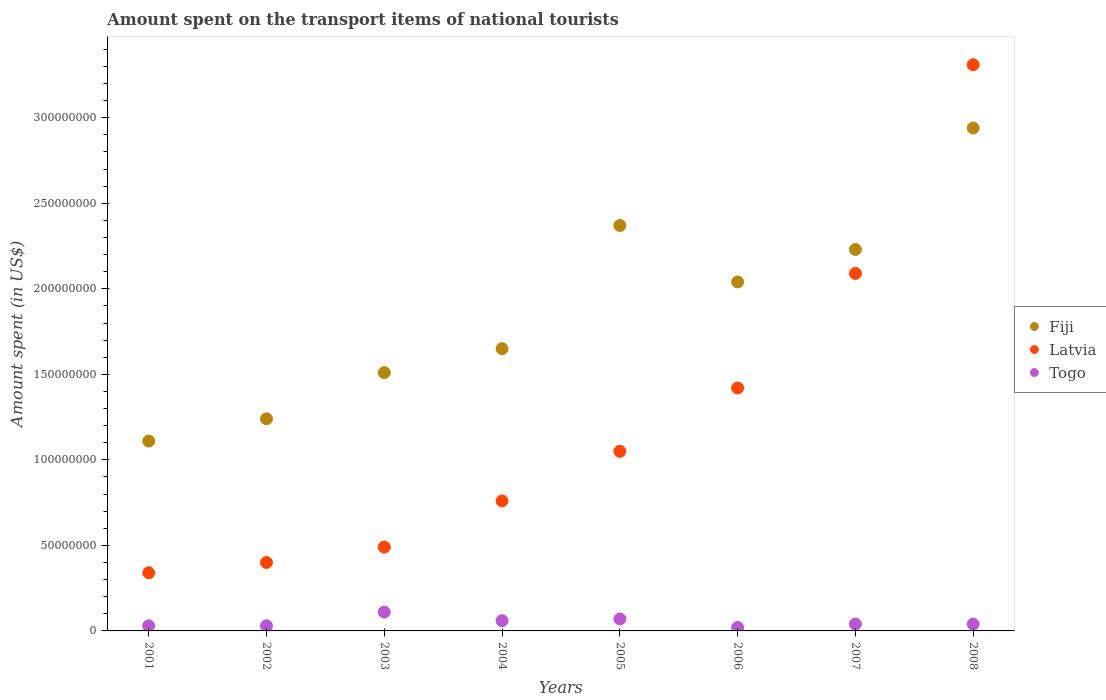Is the number of dotlines equal to the number of legend labels?
Provide a succinct answer. Yes. What is the amount spent on the transport items of national tourists in Fiji in 2002?
Ensure brevity in your answer.  1.24e+08. Across all years, what is the maximum amount spent on the transport items of national tourists in Togo?
Your answer should be very brief. 1.10e+07. Across all years, what is the minimum amount spent on the transport items of national tourists in Latvia?
Keep it short and to the point. 3.40e+07. In which year was the amount spent on the transport items of national tourists in Togo maximum?
Your answer should be compact. 2003. What is the total amount spent on the transport items of national tourists in Latvia in the graph?
Give a very brief answer. 9.86e+08. What is the difference between the amount spent on the transport items of national tourists in Fiji in 2006 and the amount spent on the transport items of national tourists in Togo in 2007?
Provide a succinct answer. 2.00e+08. What is the average amount spent on the transport items of national tourists in Latvia per year?
Your response must be concise. 1.23e+08. In the year 2006, what is the difference between the amount spent on the transport items of national tourists in Latvia and amount spent on the transport items of national tourists in Togo?
Make the answer very short. 1.40e+08. In how many years, is the amount spent on the transport items of national tourists in Fiji greater than 20000000 US$?
Provide a succinct answer. 8. What is the ratio of the amount spent on the transport items of national tourists in Togo in 2001 to that in 2005?
Provide a succinct answer. 0.43. What is the difference between the highest and the second highest amount spent on the transport items of national tourists in Fiji?
Your answer should be compact. 5.70e+07. What is the difference between the highest and the lowest amount spent on the transport items of national tourists in Latvia?
Offer a terse response. 2.97e+08. In how many years, is the amount spent on the transport items of national tourists in Fiji greater than the average amount spent on the transport items of national tourists in Fiji taken over all years?
Keep it short and to the point. 4. Is it the case that in every year, the sum of the amount spent on the transport items of national tourists in Togo and amount spent on the transport items of national tourists in Latvia  is greater than the amount spent on the transport items of national tourists in Fiji?
Provide a short and direct response. No. Does the amount spent on the transport items of national tourists in Fiji monotonically increase over the years?
Your response must be concise. No. Is the amount spent on the transport items of national tourists in Fiji strictly less than the amount spent on the transport items of national tourists in Togo over the years?
Your response must be concise. No. How many years are there in the graph?
Give a very brief answer. 8. Are the values on the major ticks of Y-axis written in scientific E-notation?
Provide a succinct answer. No. Does the graph contain any zero values?
Your answer should be very brief. No. Does the graph contain grids?
Provide a short and direct response. No. How many legend labels are there?
Your answer should be very brief. 3. How are the legend labels stacked?
Your answer should be compact. Vertical. What is the title of the graph?
Make the answer very short. Amount spent on the transport items of national tourists. Does "Moldova" appear as one of the legend labels in the graph?
Your answer should be very brief. No. What is the label or title of the Y-axis?
Provide a succinct answer. Amount spent (in US$). What is the Amount spent (in US$) of Fiji in 2001?
Your answer should be very brief. 1.11e+08. What is the Amount spent (in US$) of Latvia in 2001?
Your answer should be compact. 3.40e+07. What is the Amount spent (in US$) of Togo in 2001?
Ensure brevity in your answer.  3.00e+06. What is the Amount spent (in US$) in Fiji in 2002?
Offer a very short reply. 1.24e+08. What is the Amount spent (in US$) in Latvia in 2002?
Your response must be concise. 4.00e+07. What is the Amount spent (in US$) of Togo in 2002?
Offer a very short reply. 3.00e+06. What is the Amount spent (in US$) in Fiji in 2003?
Your response must be concise. 1.51e+08. What is the Amount spent (in US$) of Latvia in 2003?
Provide a succinct answer. 4.90e+07. What is the Amount spent (in US$) of Togo in 2003?
Make the answer very short. 1.10e+07. What is the Amount spent (in US$) in Fiji in 2004?
Your answer should be compact. 1.65e+08. What is the Amount spent (in US$) in Latvia in 2004?
Your answer should be very brief. 7.60e+07. What is the Amount spent (in US$) in Fiji in 2005?
Keep it short and to the point. 2.37e+08. What is the Amount spent (in US$) of Latvia in 2005?
Give a very brief answer. 1.05e+08. What is the Amount spent (in US$) of Fiji in 2006?
Offer a terse response. 2.04e+08. What is the Amount spent (in US$) in Latvia in 2006?
Offer a terse response. 1.42e+08. What is the Amount spent (in US$) in Togo in 2006?
Provide a short and direct response. 2.00e+06. What is the Amount spent (in US$) of Fiji in 2007?
Keep it short and to the point. 2.23e+08. What is the Amount spent (in US$) in Latvia in 2007?
Your response must be concise. 2.09e+08. What is the Amount spent (in US$) in Togo in 2007?
Your answer should be compact. 4.00e+06. What is the Amount spent (in US$) of Fiji in 2008?
Provide a succinct answer. 2.94e+08. What is the Amount spent (in US$) of Latvia in 2008?
Ensure brevity in your answer.  3.31e+08. Across all years, what is the maximum Amount spent (in US$) of Fiji?
Make the answer very short. 2.94e+08. Across all years, what is the maximum Amount spent (in US$) of Latvia?
Give a very brief answer. 3.31e+08. Across all years, what is the maximum Amount spent (in US$) of Togo?
Make the answer very short. 1.10e+07. Across all years, what is the minimum Amount spent (in US$) of Fiji?
Provide a short and direct response. 1.11e+08. Across all years, what is the minimum Amount spent (in US$) of Latvia?
Make the answer very short. 3.40e+07. What is the total Amount spent (in US$) of Fiji in the graph?
Your answer should be very brief. 1.51e+09. What is the total Amount spent (in US$) in Latvia in the graph?
Offer a very short reply. 9.86e+08. What is the total Amount spent (in US$) in Togo in the graph?
Offer a terse response. 4.00e+07. What is the difference between the Amount spent (in US$) of Fiji in 2001 and that in 2002?
Offer a terse response. -1.30e+07. What is the difference between the Amount spent (in US$) of Latvia in 2001 and that in 2002?
Your answer should be compact. -6.00e+06. What is the difference between the Amount spent (in US$) in Fiji in 2001 and that in 2003?
Keep it short and to the point. -4.00e+07. What is the difference between the Amount spent (in US$) of Latvia in 2001 and that in 2003?
Your answer should be compact. -1.50e+07. What is the difference between the Amount spent (in US$) of Togo in 2001 and that in 2003?
Provide a succinct answer. -8.00e+06. What is the difference between the Amount spent (in US$) of Fiji in 2001 and that in 2004?
Your response must be concise. -5.40e+07. What is the difference between the Amount spent (in US$) in Latvia in 2001 and that in 2004?
Your answer should be very brief. -4.20e+07. What is the difference between the Amount spent (in US$) in Togo in 2001 and that in 2004?
Provide a short and direct response. -3.00e+06. What is the difference between the Amount spent (in US$) in Fiji in 2001 and that in 2005?
Your answer should be compact. -1.26e+08. What is the difference between the Amount spent (in US$) of Latvia in 2001 and that in 2005?
Offer a terse response. -7.10e+07. What is the difference between the Amount spent (in US$) in Fiji in 2001 and that in 2006?
Your answer should be compact. -9.30e+07. What is the difference between the Amount spent (in US$) of Latvia in 2001 and that in 2006?
Your answer should be very brief. -1.08e+08. What is the difference between the Amount spent (in US$) of Fiji in 2001 and that in 2007?
Your response must be concise. -1.12e+08. What is the difference between the Amount spent (in US$) of Latvia in 2001 and that in 2007?
Provide a succinct answer. -1.75e+08. What is the difference between the Amount spent (in US$) of Fiji in 2001 and that in 2008?
Provide a short and direct response. -1.83e+08. What is the difference between the Amount spent (in US$) of Latvia in 2001 and that in 2008?
Offer a very short reply. -2.97e+08. What is the difference between the Amount spent (in US$) of Fiji in 2002 and that in 2003?
Provide a succinct answer. -2.70e+07. What is the difference between the Amount spent (in US$) of Latvia in 2002 and that in 2003?
Your response must be concise. -9.00e+06. What is the difference between the Amount spent (in US$) in Togo in 2002 and that in 2003?
Keep it short and to the point. -8.00e+06. What is the difference between the Amount spent (in US$) of Fiji in 2002 and that in 2004?
Your answer should be very brief. -4.10e+07. What is the difference between the Amount spent (in US$) in Latvia in 2002 and that in 2004?
Your answer should be compact. -3.60e+07. What is the difference between the Amount spent (in US$) in Togo in 2002 and that in 2004?
Your answer should be very brief. -3.00e+06. What is the difference between the Amount spent (in US$) of Fiji in 2002 and that in 2005?
Your answer should be compact. -1.13e+08. What is the difference between the Amount spent (in US$) in Latvia in 2002 and that in 2005?
Provide a succinct answer. -6.50e+07. What is the difference between the Amount spent (in US$) in Fiji in 2002 and that in 2006?
Provide a succinct answer. -8.00e+07. What is the difference between the Amount spent (in US$) of Latvia in 2002 and that in 2006?
Provide a succinct answer. -1.02e+08. What is the difference between the Amount spent (in US$) in Togo in 2002 and that in 2006?
Your response must be concise. 1.00e+06. What is the difference between the Amount spent (in US$) in Fiji in 2002 and that in 2007?
Your answer should be very brief. -9.90e+07. What is the difference between the Amount spent (in US$) in Latvia in 2002 and that in 2007?
Provide a succinct answer. -1.69e+08. What is the difference between the Amount spent (in US$) of Fiji in 2002 and that in 2008?
Keep it short and to the point. -1.70e+08. What is the difference between the Amount spent (in US$) in Latvia in 2002 and that in 2008?
Give a very brief answer. -2.91e+08. What is the difference between the Amount spent (in US$) in Fiji in 2003 and that in 2004?
Ensure brevity in your answer.  -1.40e+07. What is the difference between the Amount spent (in US$) in Latvia in 2003 and that in 2004?
Keep it short and to the point. -2.70e+07. What is the difference between the Amount spent (in US$) in Fiji in 2003 and that in 2005?
Ensure brevity in your answer.  -8.60e+07. What is the difference between the Amount spent (in US$) of Latvia in 2003 and that in 2005?
Offer a very short reply. -5.60e+07. What is the difference between the Amount spent (in US$) of Togo in 2003 and that in 2005?
Provide a short and direct response. 4.00e+06. What is the difference between the Amount spent (in US$) of Fiji in 2003 and that in 2006?
Give a very brief answer. -5.30e+07. What is the difference between the Amount spent (in US$) of Latvia in 2003 and that in 2006?
Offer a terse response. -9.30e+07. What is the difference between the Amount spent (in US$) of Togo in 2003 and that in 2006?
Your answer should be compact. 9.00e+06. What is the difference between the Amount spent (in US$) of Fiji in 2003 and that in 2007?
Your answer should be compact. -7.20e+07. What is the difference between the Amount spent (in US$) in Latvia in 2003 and that in 2007?
Make the answer very short. -1.60e+08. What is the difference between the Amount spent (in US$) of Fiji in 2003 and that in 2008?
Ensure brevity in your answer.  -1.43e+08. What is the difference between the Amount spent (in US$) in Latvia in 2003 and that in 2008?
Give a very brief answer. -2.82e+08. What is the difference between the Amount spent (in US$) of Togo in 2003 and that in 2008?
Make the answer very short. 7.00e+06. What is the difference between the Amount spent (in US$) in Fiji in 2004 and that in 2005?
Your answer should be very brief. -7.20e+07. What is the difference between the Amount spent (in US$) in Latvia in 2004 and that in 2005?
Provide a short and direct response. -2.90e+07. What is the difference between the Amount spent (in US$) of Togo in 2004 and that in 2005?
Offer a very short reply. -1.00e+06. What is the difference between the Amount spent (in US$) of Fiji in 2004 and that in 2006?
Provide a succinct answer. -3.90e+07. What is the difference between the Amount spent (in US$) in Latvia in 2004 and that in 2006?
Your answer should be compact. -6.60e+07. What is the difference between the Amount spent (in US$) in Fiji in 2004 and that in 2007?
Your answer should be very brief. -5.80e+07. What is the difference between the Amount spent (in US$) in Latvia in 2004 and that in 2007?
Your answer should be very brief. -1.33e+08. What is the difference between the Amount spent (in US$) in Fiji in 2004 and that in 2008?
Your response must be concise. -1.29e+08. What is the difference between the Amount spent (in US$) in Latvia in 2004 and that in 2008?
Keep it short and to the point. -2.55e+08. What is the difference between the Amount spent (in US$) of Fiji in 2005 and that in 2006?
Provide a succinct answer. 3.30e+07. What is the difference between the Amount spent (in US$) in Latvia in 2005 and that in 2006?
Your response must be concise. -3.70e+07. What is the difference between the Amount spent (in US$) of Fiji in 2005 and that in 2007?
Offer a very short reply. 1.40e+07. What is the difference between the Amount spent (in US$) in Latvia in 2005 and that in 2007?
Provide a succinct answer. -1.04e+08. What is the difference between the Amount spent (in US$) in Fiji in 2005 and that in 2008?
Provide a short and direct response. -5.70e+07. What is the difference between the Amount spent (in US$) of Latvia in 2005 and that in 2008?
Keep it short and to the point. -2.26e+08. What is the difference between the Amount spent (in US$) of Togo in 2005 and that in 2008?
Offer a very short reply. 3.00e+06. What is the difference between the Amount spent (in US$) in Fiji in 2006 and that in 2007?
Offer a very short reply. -1.90e+07. What is the difference between the Amount spent (in US$) in Latvia in 2006 and that in 2007?
Provide a short and direct response. -6.70e+07. What is the difference between the Amount spent (in US$) in Fiji in 2006 and that in 2008?
Your answer should be very brief. -9.00e+07. What is the difference between the Amount spent (in US$) in Latvia in 2006 and that in 2008?
Offer a very short reply. -1.89e+08. What is the difference between the Amount spent (in US$) of Fiji in 2007 and that in 2008?
Make the answer very short. -7.10e+07. What is the difference between the Amount spent (in US$) in Latvia in 2007 and that in 2008?
Your answer should be very brief. -1.22e+08. What is the difference between the Amount spent (in US$) of Fiji in 2001 and the Amount spent (in US$) of Latvia in 2002?
Provide a succinct answer. 7.10e+07. What is the difference between the Amount spent (in US$) in Fiji in 2001 and the Amount spent (in US$) in Togo in 2002?
Provide a short and direct response. 1.08e+08. What is the difference between the Amount spent (in US$) of Latvia in 2001 and the Amount spent (in US$) of Togo in 2002?
Offer a very short reply. 3.10e+07. What is the difference between the Amount spent (in US$) in Fiji in 2001 and the Amount spent (in US$) in Latvia in 2003?
Provide a succinct answer. 6.20e+07. What is the difference between the Amount spent (in US$) in Fiji in 2001 and the Amount spent (in US$) in Togo in 2003?
Your response must be concise. 1.00e+08. What is the difference between the Amount spent (in US$) in Latvia in 2001 and the Amount spent (in US$) in Togo in 2003?
Ensure brevity in your answer.  2.30e+07. What is the difference between the Amount spent (in US$) of Fiji in 2001 and the Amount spent (in US$) of Latvia in 2004?
Provide a short and direct response. 3.50e+07. What is the difference between the Amount spent (in US$) of Fiji in 2001 and the Amount spent (in US$) of Togo in 2004?
Keep it short and to the point. 1.05e+08. What is the difference between the Amount spent (in US$) in Latvia in 2001 and the Amount spent (in US$) in Togo in 2004?
Provide a succinct answer. 2.80e+07. What is the difference between the Amount spent (in US$) of Fiji in 2001 and the Amount spent (in US$) of Latvia in 2005?
Your answer should be compact. 6.00e+06. What is the difference between the Amount spent (in US$) in Fiji in 2001 and the Amount spent (in US$) in Togo in 2005?
Ensure brevity in your answer.  1.04e+08. What is the difference between the Amount spent (in US$) in Latvia in 2001 and the Amount spent (in US$) in Togo in 2005?
Offer a terse response. 2.70e+07. What is the difference between the Amount spent (in US$) in Fiji in 2001 and the Amount spent (in US$) in Latvia in 2006?
Your answer should be compact. -3.10e+07. What is the difference between the Amount spent (in US$) in Fiji in 2001 and the Amount spent (in US$) in Togo in 2006?
Your answer should be very brief. 1.09e+08. What is the difference between the Amount spent (in US$) in Latvia in 2001 and the Amount spent (in US$) in Togo in 2006?
Ensure brevity in your answer.  3.20e+07. What is the difference between the Amount spent (in US$) in Fiji in 2001 and the Amount spent (in US$) in Latvia in 2007?
Keep it short and to the point. -9.80e+07. What is the difference between the Amount spent (in US$) in Fiji in 2001 and the Amount spent (in US$) in Togo in 2007?
Keep it short and to the point. 1.07e+08. What is the difference between the Amount spent (in US$) of Latvia in 2001 and the Amount spent (in US$) of Togo in 2007?
Provide a succinct answer. 3.00e+07. What is the difference between the Amount spent (in US$) of Fiji in 2001 and the Amount spent (in US$) of Latvia in 2008?
Offer a very short reply. -2.20e+08. What is the difference between the Amount spent (in US$) of Fiji in 2001 and the Amount spent (in US$) of Togo in 2008?
Make the answer very short. 1.07e+08. What is the difference between the Amount spent (in US$) in Latvia in 2001 and the Amount spent (in US$) in Togo in 2008?
Offer a terse response. 3.00e+07. What is the difference between the Amount spent (in US$) of Fiji in 2002 and the Amount spent (in US$) of Latvia in 2003?
Keep it short and to the point. 7.50e+07. What is the difference between the Amount spent (in US$) in Fiji in 2002 and the Amount spent (in US$) in Togo in 2003?
Keep it short and to the point. 1.13e+08. What is the difference between the Amount spent (in US$) in Latvia in 2002 and the Amount spent (in US$) in Togo in 2003?
Ensure brevity in your answer.  2.90e+07. What is the difference between the Amount spent (in US$) of Fiji in 2002 and the Amount spent (in US$) of Latvia in 2004?
Give a very brief answer. 4.80e+07. What is the difference between the Amount spent (in US$) in Fiji in 2002 and the Amount spent (in US$) in Togo in 2004?
Ensure brevity in your answer.  1.18e+08. What is the difference between the Amount spent (in US$) of Latvia in 2002 and the Amount spent (in US$) of Togo in 2004?
Make the answer very short. 3.40e+07. What is the difference between the Amount spent (in US$) of Fiji in 2002 and the Amount spent (in US$) of Latvia in 2005?
Your answer should be very brief. 1.90e+07. What is the difference between the Amount spent (in US$) in Fiji in 2002 and the Amount spent (in US$) in Togo in 2005?
Your answer should be compact. 1.17e+08. What is the difference between the Amount spent (in US$) in Latvia in 2002 and the Amount spent (in US$) in Togo in 2005?
Provide a short and direct response. 3.30e+07. What is the difference between the Amount spent (in US$) of Fiji in 2002 and the Amount spent (in US$) of Latvia in 2006?
Your answer should be very brief. -1.80e+07. What is the difference between the Amount spent (in US$) in Fiji in 2002 and the Amount spent (in US$) in Togo in 2006?
Your answer should be very brief. 1.22e+08. What is the difference between the Amount spent (in US$) in Latvia in 2002 and the Amount spent (in US$) in Togo in 2006?
Give a very brief answer. 3.80e+07. What is the difference between the Amount spent (in US$) in Fiji in 2002 and the Amount spent (in US$) in Latvia in 2007?
Your answer should be compact. -8.50e+07. What is the difference between the Amount spent (in US$) in Fiji in 2002 and the Amount spent (in US$) in Togo in 2007?
Your answer should be very brief. 1.20e+08. What is the difference between the Amount spent (in US$) of Latvia in 2002 and the Amount spent (in US$) of Togo in 2007?
Make the answer very short. 3.60e+07. What is the difference between the Amount spent (in US$) in Fiji in 2002 and the Amount spent (in US$) in Latvia in 2008?
Your answer should be compact. -2.07e+08. What is the difference between the Amount spent (in US$) of Fiji in 2002 and the Amount spent (in US$) of Togo in 2008?
Keep it short and to the point. 1.20e+08. What is the difference between the Amount spent (in US$) of Latvia in 2002 and the Amount spent (in US$) of Togo in 2008?
Provide a succinct answer. 3.60e+07. What is the difference between the Amount spent (in US$) in Fiji in 2003 and the Amount spent (in US$) in Latvia in 2004?
Make the answer very short. 7.50e+07. What is the difference between the Amount spent (in US$) in Fiji in 2003 and the Amount spent (in US$) in Togo in 2004?
Give a very brief answer. 1.45e+08. What is the difference between the Amount spent (in US$) of Latvia in 2003 and the Amount spent (in US$) of Togo in 2004?
Offer a terse response. 4.30e+07. What is the difference between the Amount spent (in US$) of Fiji in 2003 and the Amount spent (in US$) of Latvia in 2005?
Keep it short and to the point. 4.60e+07. What is the difference between the Amount spent (in US$) in Fiji in 2003 and the Amount spent (in US$) in Togo in 2005?
Your answer should be compact. 1.44e+08. What is the difference between the Amount spent (in US$) in Latvia in 2003 and the Amount spent (in US$) in Togo in 2005?
Your answer should be compact. 4.20e+07. What is the difference between the Amount spent (in US$) of Fiji in 2003 and the Amount spent (in US$) of Latvia in 2006?
Your answer should be very brief. 9.00e+06. What is the difference between the Amount spent (in US$) of Fiji in 2003 and the Amount spent (in US$) of Togo in 2006?
Ensure brevity in your answer.  1.49e+08. What is the difference between the Amount spent (in US$) in Latvia in 2003 and the Amount spent (in US$) in Togo in 2006?
Your answer should be very brief. 4.70e+07. What is the difference between the Amount spent (in US$) in Fiji in 2003 and the Amount spent (in US$) in Latvia in 2007?
Provide a short and direct response. -5.80e+07. What is the difference between the Amount spent (in US$) in Fiji in 2003 and the Amount spent (in US$) in Togo in 2007?
Provide a short and direct response. 1.47e+08. What is the difference between the Amount spent (in US$) in Latvia in 2003 and the Amount spent (in US$) in Togo in 2007?
Ensure brevity in your answer.  4.50e+07. What is the difference between the Amount spent (in US$) in Fiji in 2003 and the Amount spent (in US$) in Latvia in 2008?
Provide a succinct answer. -1.80e+08. What is the difference between the Amount spent (in US$) in Fiji in 2003 and the Amount spent (in US$) in Togo in 2008?
Ensure brevity in your answer.  1.47e+08. What is the difference between the Amount spent (in US$) of Latvia in 2003 and the Amount spent (in US$) of Togo in 2008?
Offer a terse response. 4.50e+07. What is the difference between the Amount spent (in US$) in Fiji in 2004 and the Amount spent (in US$) in Latvia in 2005?
Make the answer very short. 6.00e+07. What is the difference between the Amount spent (in US$) in Fiji in 2004 and the Amount spent (in US$) in Togo in 2005?
Provide a succinct answer. 1.58e+08. What is the difference between the Amount spent (in US$) of Latvia in 2004 and the Amount spent (in US$) of Togo in 2005?
Keep it short and to the point. 6.90e+07. What is the difference between the Amount spent (in US$) of Fiji in 2004 and the Amount spent (in US$) of Latvia in 2006?
Your response must be concise. 2.30e+07. What is the difference between the Amount spent (in US$) of Fiji in 2004 and the Amount spent (in US$) of Togo in 2006?
Give a very brief answer. 1.63e+08. What is the difference between the Amount spent (in US$) of Latvia in 2004 and the Amount spent (in US$) of Togo in 2006?
Provide a short and direct response. 7.40e+07. What is the difference between the Amount spent (in US$) in Fiji in 2004 and the Amount spent (in US$) in Latvia in 2007?
Offer a terse response. -4.40e+07. What is the difference between the Amount spent (in US$) in Fiji in 2004 and the Amount spent (in US$) in Togo in 2007?
Offer a very short reply. 1.61e+08. What is the difference between the Amount spent (in US$) of Latvia in 2004 and the Amount spent (in US$) of Togo in 2007?
Your answer should be very brief. 7.20e+07. What is the difference between the Amount spent (in US$) in Fiji in 2004 and the Amount spent (in US$) in Latvia in 2008?
Provide a succinct answer. -1.66e+08. What is the difference between the Amount spent (in US$) in Fiji in 2004 and the Amount spent (in US$) in Togo in 2008?
Your answer should be compact. 1.61e+08. What is the difference between the Amount spent (in US$) of Latvia in 2004 and the Amount spent (in US$) of Togo in 2008?
Make the answer very short. 7.20e+07. What is the difference between the Amount spent (in US$) of Fiji in 2005 and the Amount spent (in US$) of Latvia in 2006?
Keep it short and to the point. 9.50e+07. What is the difference between the Amount spent (in US$) in Fiji in 2005 and the Amount spent (in US$) in Togo in 2006?
Offer a terse response. 2.35e+08. What is the difference between the Amount spent (in US$) in Latvia in 2005 and the Amount spent (in US$) in Togo in 2006?
Offer a very short reply. 1.03e+08. What is the difference between the Amount spent (in US$) of Fiji in 2005 and the Amount spent (in US$) of Latvia in 2007?
Offer a very short reply. 2.80e+07. What is the difference between the Amount spent (in US$) of Fiji in 2005 and the Amount spent (in US$) of Togo in 2007?
Your answer should be very brief. 2.33e+08. What is the difference between the Amount spent (in US$) of Latvia in 2005 and the Amount spent (in US$) of Togo in 2007?
Give a very brief answer. 1.01e+08. What is the difference between the Amount spent (in US$) in Fiji in 2005 and the Amount spent (in US$) in Latvia in 2008?
Offer a terse response. -9.40e+07. What is the difference between the Amount spent (in US$) of Fiji in 2005 and the Amount spent (in US$) of Togo in 2008?
Keep it short and to the point. 2.33e+08. What is the difference between the Amount spent (in US$) in Latvia in 2005 and the Amount spent (in US$) in Togo in 2008?
Ensure brevity in your answer.  1.01e+08. What is the difference between the Amount spent (in US$) of Fiji in 2006 and the Amount spent (in US$) of Latvia in 2007?
Offer a very short reply. -5.00e+06. What is the difference between the Amount spent (in US$) in Fiji in 2006 and the Amount spent (in US$) in Togo in 2007?
Provide a succinct answer. 2.00e+08. What is the difference between the Amount spent (in US$) in Latvia in 2006 and the Amount spent (in US$) in Togo in 2007?
Your answer should be compact. 1.38e+08. What is the difference between the Amount spent (in US$) in Fiji in 2006 and the Amount spent (in US$) in Latvia in 2008?
Provide a short and direct response. -1.27e+08. What is the difference between the Amount spent (in US$) of Fiji in 2006 and the Amount spent (in US$) of Togo in 2008?
Offer a terse response. 2.00e+08. What is the difference between the Amount spent (in US$) in Latvia in 2006 and the Amount spent (in US$) in Togo in 2008?
Your response must be concise. 1.38e+08. What is the difference between the Amount spent (in US$) of Fiji in 2007 and the Amount spent (in US$) of Latvia in 2008?
Your answer should be compact. -1.08e+08. What is the difference between the Amount spent (in US$) of Fiji in 2007 and the Amount spent (in US$) of Togo in 2008?
Keep it short and to the point. 2.19e+08. What is the difference between the Amount spent (in US$) in Latvia in 2007 and the Amount spent (in US$) in Togo in 2008?
Make the answer very short. 2.05e+08. What is the average Amount spent (in US$) in Fiji per year?
Your answer should be very brief. 1.89e+08. What is the average Amount spent (in US$) of Latvia per year?
Offer a terse response. 1.23e+08. What is the average Amount spent (in US$) of Togo per year?
Your answer should be very brief. 5.00e+06. In the year 2001, what is the difference between the Amount spent (in US$) in Fiji and Amount spent (in US$) in Latvia?
Make the answer very short. 7.70e+07. In the year 2001, what is the difference between the Amount spent (in US$) in Fiji and Amount spent (in US$) in Togo?
Offer a very short reply. 1.08e+08. In the year 2001, what is the difference between the Amount spent (in US$) in Latvia and Amount spent (in US$) in Togo?
Provide a short and direct response. 3.10e+07. In the year 2002, what is the difference between the Amount spent (in US$) of Fiji and Amount spent (in US$) of Latvia?
Offer a terse response. 8.40e+07. In the year 2002, what is the difference between the Amount spent (in US$) of Fiji and Amount spent (in US$) of Togo?
Provide a succinct answer. 1.21e+08. In the year 2002, what is the difference between the Amount spent (in US$) in Latvia and Amount spent (in US$) in Togo?
Your answer should be very brief. 3.70e+07. In the year 2003, what is the difference between the Amount spent (in US$) of Fiji and Amount spent (in US$) of Latvia?
Your response must be concise. 1.02e+08. In the year 2003, what is the difference between the Amount spent (in US$) of Fiji and Amount spent (in US$) of Togo?
Your response must be concise. 1.40e+08. In the year 2003, what is the difference between the Amount spent (in US$) of Latvia and Amount spent (in US$) of Togo?
Offer a terse response. 3.80e+07. In the year 2004, what is the difference between the Amount spent (in US$) in Fiji and Amount spent (in US$) in Latvia?
Keep it short and to the point. 8.90e+07. In the year 2004, what is the difference between the Amount spent (in US$) in Fiji and Amount spent (in US$) in Togo?
Give a very brief answer. 1.59e+08. In the year 2004, what is the difference between the Amount spent (in US$) of Latvia and Amount spent (in US$) of Togo?
Make the answer very short. 7.00e+07. In the year 2005, what is the difference between the Amount spent (in US$) in Fiji and Amount spent (in US$) in Latvia?
Ensure brevity in your answer.  1.32e+08. In the year 2005, what is the difference between the Amount spent (in US$) of Fiji and Amount spent (in US$) of Togo?
Offer a very short reply. 2.30e+08. In the year 2005, what is the difference between the Amount spent (in US$) of Latvia and Amount spent (in US$) of Togo?
Ensure brevity in your answer.  9.80e+07. In the year 2006, what is the difference between the Amount spent (in US$) of Fiji and Amount spent (in US$) of Latvia?
Offer a very short reply. 6.20e+07. In the year 2006, what is the difference between the Amount spent (in US$) of Fiji and Amount spent (in US$) of Togo?
Offer a terse response. 2.02e+08. In the year 2006, what is the difference between the Amount spent (in US$) of Latvia and Amount spent (in US$) of Togo?
Ensure brevity in your answer.  1.40e+08. In the year 2007, what is the difference between the Amount spent (in US$) in Fiji and Amount spent (in US$) in Latvia?
Give a very brief answer. 1.40e+07. In the year 2007, what is the difference between the Amount spent (in US$) of Fiji and Amount spent (in US$) of Togo?
Provide a succinct answer. 2.19e+08. In the year 2007, what is the difference between the Amount spent (in US$) in Latvia and Amount spent (in US$) in Togo?
Offer a terse response. 2.05e+08. In the year 2008, what is the difference between the Amount spent (in US$) in Fiji and Amount spent (in US$) in Latvia?
Keep it short and to the point. -3.70e+07. In the year 2008, what is the difference between the Amount spent (in US$) of Fiji and Amount spent (in US$) of Togo?
Offer a very short reply. 2.90e+08. In the year 2008, what is the difference between the Amount spent (in US$) of Latvia and Amount spent (in US$) of Togo?
Provide a succinct answer. 3.27e+08. What is the ratio of the Amount spent (in US$) of Fiji in 2001 to that in 2002?
Ensure brevity in your answer.  0.9. What is the ratio of the Amount spent (in US$) of Fiji in 2001 to that in 2003?
Your answer should be very brief. 0.74. What is the ratio of the Amount spent (in US$) in Latvia in 2001 to that in 2003?
Offer a terse response. 0.69. What is the ratio of the Amount spent (in US$) of Togo in 2001 to that in 2003?
Offer a very short reply. 0.27. What is the ratio of the Amount spent (in US$) in Fiji in 2001 to that in 2004?
Offer a terse response. 0.67. What is the ratio of the Amount spent (in US$) of Latvia in 2001 to that in 2004?
Provide a short and direct response. 0.45. What is the ratio of the Amount spent (in US$) in Togo in 2001 to that in 2004?
Offer a terse response. 0.5. What is the ratio of the Amount spent (in US$) in Fiji in 2001 to that in 2005?
Keep it short and to the point. 0.47. What is the ratio of the Amount spent (in US$) of Latvia in 2001 to that in 2005?
Your answer should be compact. 0.32. What is the ratio of the Amount spent (in US$) of Togo in 2001 to that in 2005?
Your response must be concise. 0.43. What is the ratio of the Amount spent (in US$) of Fiji in 2001 to that in 2006?
Make the answer very short. 0.54. What is the ratio of the Amount spent (in US$) in Latvia in 2001 to that in 2006?
Offer a terse response. 0.24. What is the ratio of the Amount spent (in US$) in Togo in 2001 to that in 2006?
Your answer should be compact. 1.5. What is the ratio of the Amount spent (in US$) of Fiji in 2001 to that in 2007?
Provide a succinct answer. 0.5. What is the ratio of the Amount spent (in US$) in Latvia in 2001 to that in 2007?
Make the answer very short. 0.16. What is the ratio of the Amount spent (in US$) in Togo in 2001 to that in 2007?
Offer a terse response. 0.75. What is the ratio of the Amount spent (in US$) in Fiji in 2001 to that in 2008?
Ensure brevity in your answer.  0.38. What is the ratio of the Amount spent (in US$) in Latvia in 2001 to that in 2008?
Give a very brief answer. 0.1. What is the ratio of the Amount spent (in US$) in Togo in 2001 to that in 2008?
Your response must be concise. 0.75. What is the ratio of the Amount spent (in US$) of Fiji in 2002 to that in 2003?
Give a very brief answer. 0.82. What is the ratio of the Amount spent (in US$) of Latvia in 2002 to that in 2003?
Provide a short and direct response. 0.82. What is the ratio of the Amount spent (in US$) in Togo in 2002 to that in 2003?
Provide a short and direct response. 0.27. What is the ratio of the Amount spent (in US$) in Fiji in 2002 to that in 2004?
Your response must be concise. 0.75. What is the ratio of the Amount spent (in US$) in Latvia in 2002 to that in 2004?
Your answer should be compact. 0.53. What is the ratio of the Amount spent (in US$) of Togo in 2002 to that in 2004?
Keep it short and to the point. 0.5. What is the ratio of the Amount spent (in US$) of Fiji in 2002 to that in 2005?
Your answer should be compact. 0.52. What is the ratio of the Amount spent (in US$) in Latvia in 2002 to that in 2005?
Your answer should be very brief. 0.38. What is the ratio of the Amount spent (in US$) of Togo in 2002 to that in 2005?
Your response must be concise. 0.43. What is the ratio of the Amount spent (in US$) in Fiji in 2002 to that in 2006?
Provide a short and direct response. 0.61. What is the ratio of the Amount spent (in US$) in Latvia in 2002 to that in 2006?
Provide a short and direct response. 0.28. What is the ratio of the Amount spent (in US$) of Fiji in 2002 to that in 2007?
Provide a succinct answer. 0.56. What is the ratio of the Amount spent (in US$) of Latvia in 2002 to that in 2007?
Give a very brief answer. 0.19. What is the ratio of the Amount spent (in US$) in Togo in 2002 to that in 2007?
Offer a very short reply. 0.75. What is the ratio of the Amount spent (in US$) of Fiji in 2002 to that in 2008?
Make the answer very short. 0.42. What is the ratio of the Amount spent (in US$) in Latvia in 2002 to that in 2008?
Provide a short and direct response. 0.12. What is the ratio of the Amount spent (in US$) of Fiji in 2003 to that in 2004?
Offer a very short reply. 0.92. What is the ratio of the Amount spent (in US$) in Latvia in 2003 to that in 2004?
Offer a very short reply. 0.64. What is the ratio of the Amount spent (in US$) of Togo in 2003 to that in 2004?
Provide a succinct answer. 1.83. What is the ratio of the Amount spent (in US$) of Fiji in 2003 to that in 2005?
Your response must be concise. 0.64. What is the ratio of the Amount spent (in US$) of Latvia in 2003 to that in 2005?
Make the answer very short. 0.47. What is the ratio of the Amount spent (in US$) of Togo in 2003 to that in 2005?
Keep it short and to the point. 1.57. What is the ratio of the Amount spent (in US$) in Fiji in 2003 to that in 2006?
Keep it short and to the point. 0.74. What is the ratio of the Amount spent (in US$) of Latvia in 2003 to that in 2006?
Offer a terse response. 0.35. What is the ratio of the Amount spent (in US$) of Fiji in 2003 to that in 2007?
Your answer should be compact. 0.68. What is the ratio of the Amount spent (in US$) of Latvia in 2003 to that in 2007?
Your answer should be compact. 0.23. What is the ratio of the Amount spent (in US$) of Togo in 2003 to that in 2007?
Offer a terse response. 2.75. What is the ratio of the Amount spent (in US$) in Fiji in 2003 to that in 2008?
Offer a terse response. 0.51. What is the ratio of the Amount spent (in US$) of Latvia in 2003 to that in 2008?
Keep it short and to the point. 0.15. What is the ratio of the Amount spent (in US$) of Togo in 2003 to that in 2008?
Offer a very short reply. 2.75. What is the ratio of the Amount spent (in US$) of Fiji in 2004 to that in 2005?
Your answer should be compact. 0.7. What is the ratio of the Amount spent (in US$) of Latvia in 2004 to that in 2005?
Provide a succinct answer. 0.72. What is the ratio of the Amount spent (in US$) in Togo in 2004 to that in 2005?
Provide a succinct answer. 0.86. What is the ratio of the Amount spent (in US$) of Fiji in 2004 to that in 2006?
Ensure brevity in your answer.  0.81. What is the ratio of the Amount spent (in US$) in Latvia in 2004 to that in 2006?
Offer a terse response. 0.54. What is the ratio of the Amount spent (in US$) of Fiji in 2004 to that in 2007?
Your answer should be compact. 0.74. What is the ratio of the Amount spent (in US$) in Latvia in 2004 to that in 2007?
Provide a succinct answer. 0.36. What is the ratio of the Amount spent (in US$) of Fiji in 2004 to that in 2008?
Give a very brief answer. 0.56. What is the ratio of the Amount spent (in US$) in Latvia in 2004 to that in 2008?
Your answer should be very brief. 0.23. What is the ratio of the Amount spent (in US$) of Togo in 2004 to that in 2008?
Give a very brief answer. 1.5. What is the ratio of the Amount spent (in US$) of Fiji in 2005 to that in 2006?
Your answer should be compact. 1.16. What is the ratio of the Amount spent (in US$) in Latvia in 2005 to that in 2006?
Your answer should be compact. 0.74. What is the ratio of the Amount spent (in US$) in Fiji in 2005 to that in 2007?
Keep it short and to the point. 1.06. What is the ratio of the Amount spent (in US$) in Latvia in 2005 to that in 2007?
Keep it short and to the point. 0.5. What is the ratio of the Amount spent (in US$) of Fiji in 2005 to that in 2008?
Your answer should be compact. 0.81. What is the ratio of the Amount spent (in US$) of Latvia in 2005 to that in 2008?
Give a very brief answer. 0.32. What is the ratio of the Amount spent (in US$) in Togo in 2005 to that in 2008?
Make the answer very short. 1.75. What is the ratio of the Amount spent (in US$) of Fiji in 2006 to that in 2007?
Offer a very short reply. 0.91. What is the ratio of the Amount spent (in US$) of Latvia in 2006 to that in 2007?
Make the answer very short. 0.68. What is the ratio of the Amount spent (in US$) in Fiji in 2006 to that in 2008?
Your answer should be compact. 0.69. What is the ratio of the Amount spent (in US$) in Latvia in 2006 to that in 2008?
Provide a short and direct response. 0.43. What is the ratio of the Amount spent (in US$) in Togo in 2006 to that in 2008?
Offer a terse response. 0.5. What is the ratio of the Amount spent (in US$) in Fiji in 2007 to that in 2008?
Your answer should be very brief. 0.76. What is the ratio of the Amount spent (in US$) of Latvia in 2007 to that in 2008?
Your answer should be compact. 0.63. What is the difference between the highest and the second highest Amount spent (in US$) in Fiji?
Your answer should be very brief. 5.70e+07. What is the difference between the highest and the second highest Amount spent (in US$) in Latvia?
Ensure brevity in your answer.  1.22e+08. What is the difference between the highest and the second highest Amount spent (in US$) in Togo?
Your response must be concise. 4.00e+06. What is the difference between the highest and the lowest Amount spent (in US$) of Fiji?
Ensure brevity in your answer.  1.83e+08. What is the difference between the highest and the lowest Amount spent (in US$) of Latvia?
Offer a very short reply. 2.97e+08. What is the difference between the highest and the lowest Amount spent (in US$) of Togo?
Your answer should be very brief. 9.00e+06. 